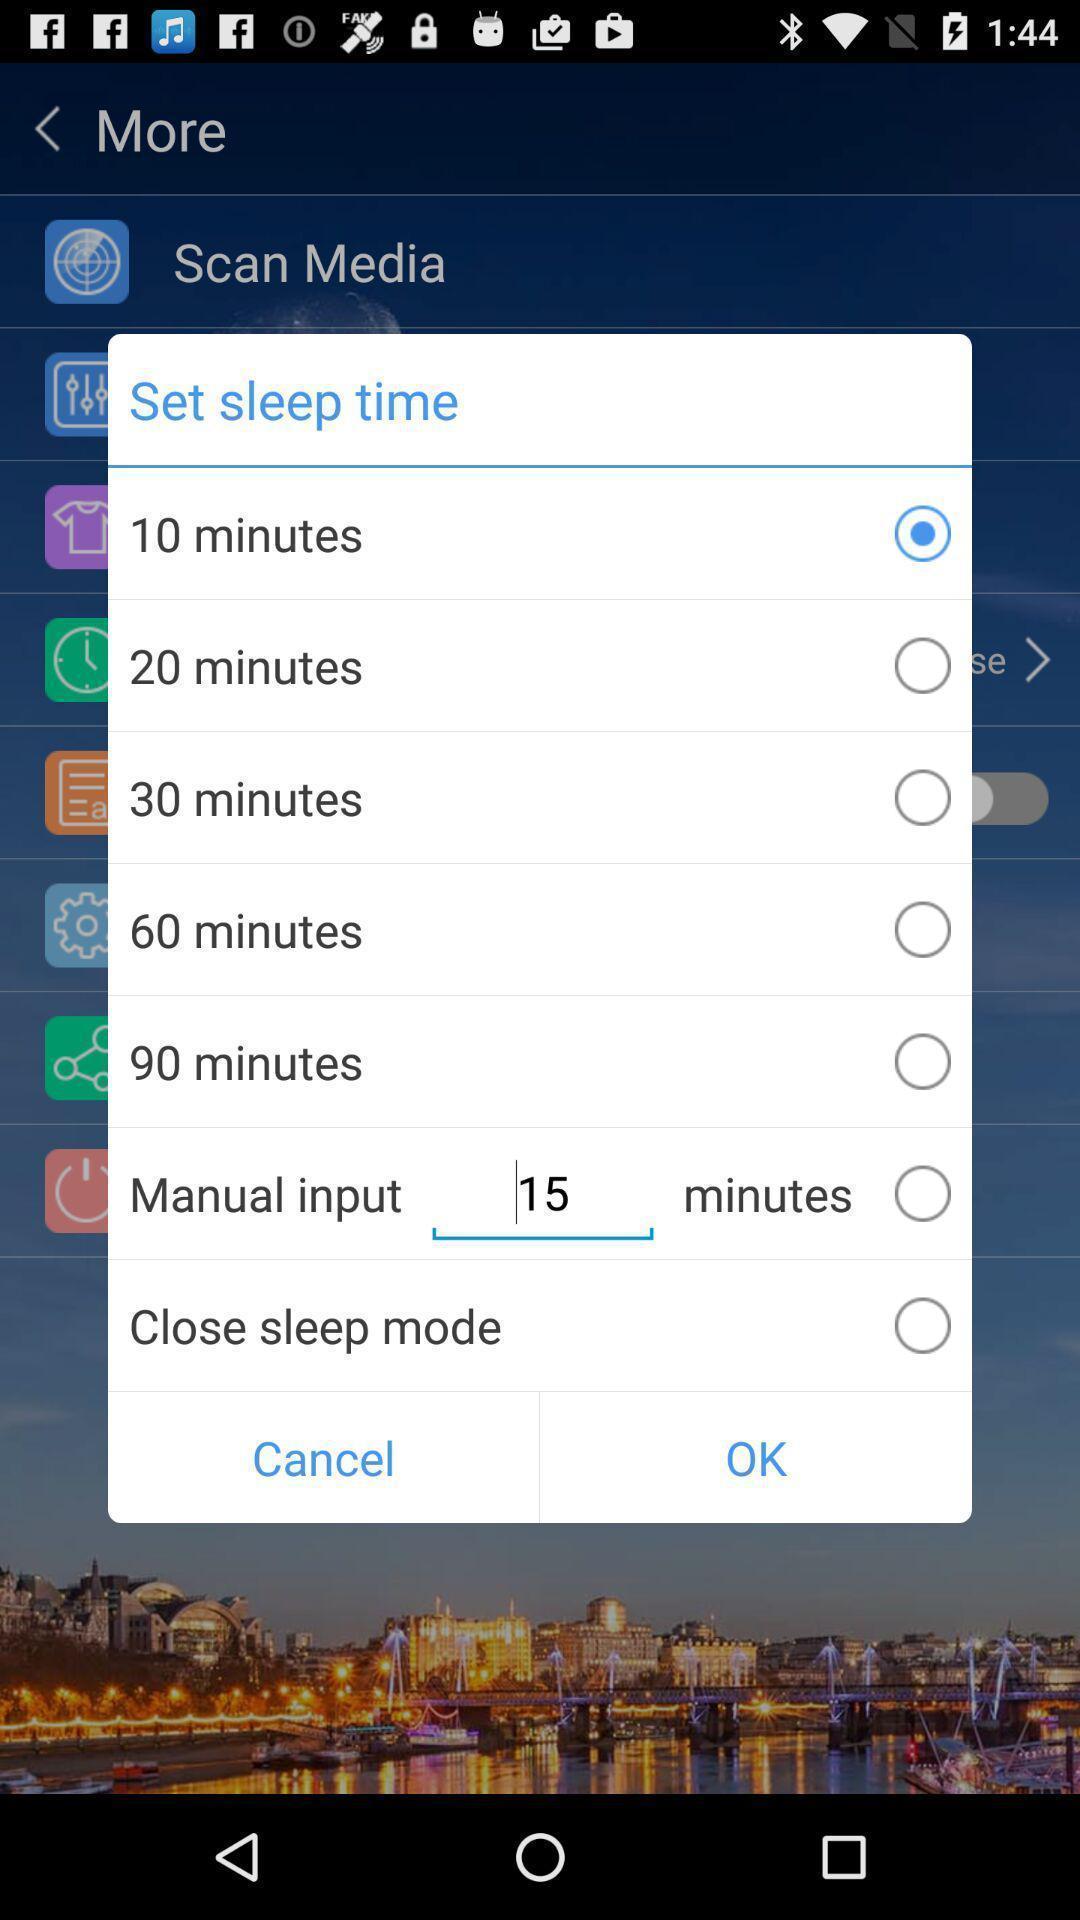What details can you identify in this image? Pop-up to set a sleep time. 